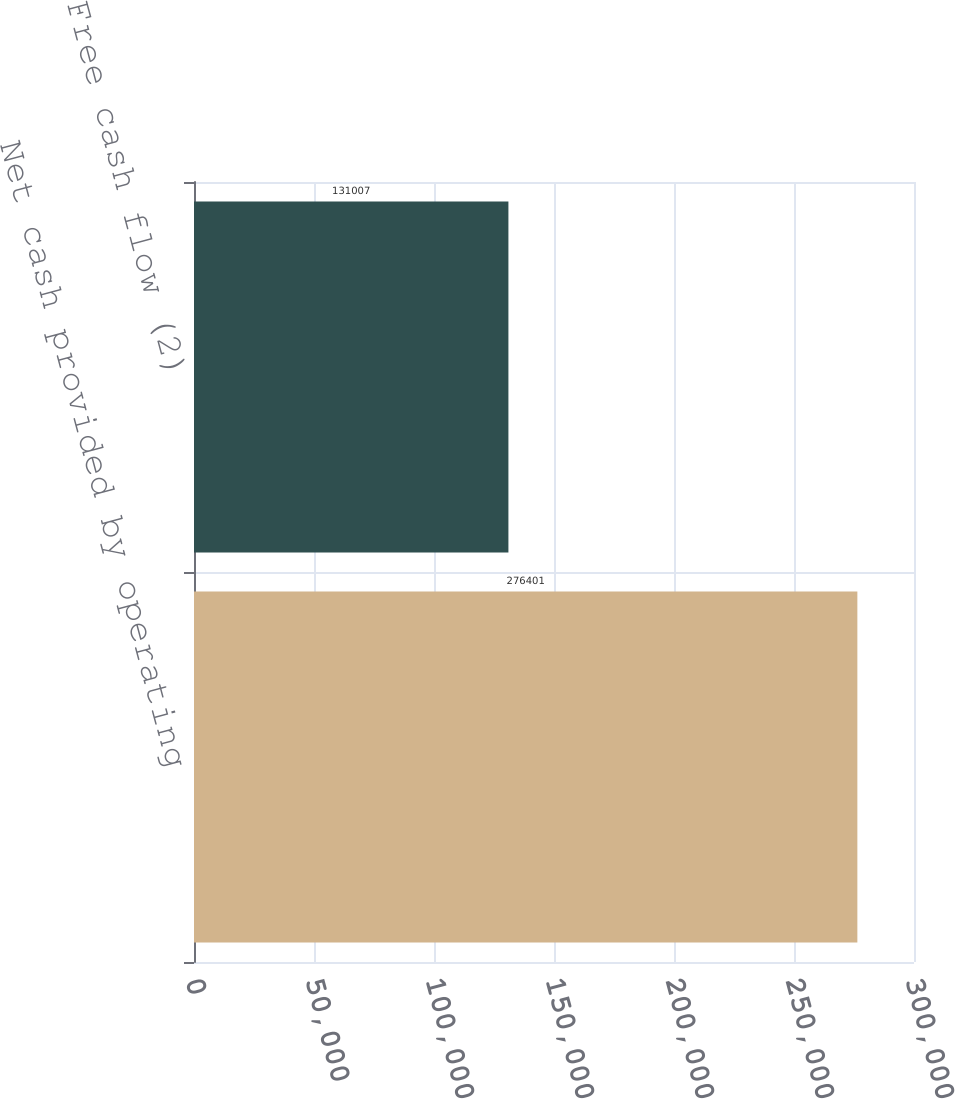Convert chart. <chart><loc_0><loc_0><loc_500><loc_500><bar_chart><fcel>Net cash provided by operating<fcel>Free cash flow (2)<nl><fcel>276401<fcel>131007<nl></chart> 